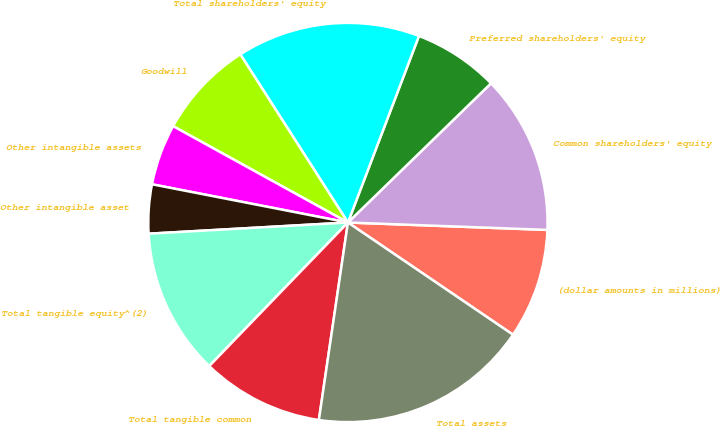Convert chart to OTSL. <chart><loc_0><loc_0><loc_500><loc_500><pie_chart><fcel>(dollar amounts in millions)<fcel>Common shareholders' equity<fcel>Preferred shareholders' equity<fcel>Total shareholders' equity<fcel>Goodwill<fcel>Other intangible assets<fcel>Other intangible asset<fcel>Total tangible equity^(2)<fcel>Total tangible common<fcel>Total assets<nl><fcel>8.91%<fcel>12.87%<fcel>6.93%<fcel>14.85%<fcel>7.92%<fcel>4.95%<fcel>3.96%<fcel>11.88%<fcel>9.9%<fcel>17.82%<nl></chart> 